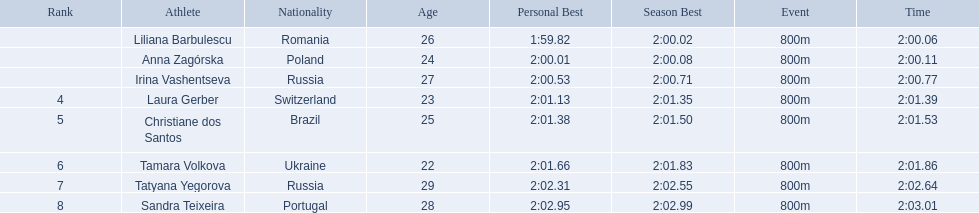What are the names of the competitors? Liliana Barbulescu, Anna Zagórska, Irina Vashentseva, Laura Gerber, Christiane dos Santos, Tamara Volkova, Tatyana Yegorova, Sandra Teixeira. Which finalist finished the fastest? Liliana Barbulescu. Who were all of the athletes? Liliana Barbulescu, Anna Zagórska, Irina Vashentseva, Laura Gerber, Christiane dos Santos, Tamara Volkova, Tatyana Yegorova, Sandra Teixeira. What were their finishing times? 2:00.06, 2:00.11, 2:00.77, 2:01.39, 2:01.53, 2:01.86, 2:02.64, 2:03.01. Which athlete finished earliest? Liliana Barbulescu. 